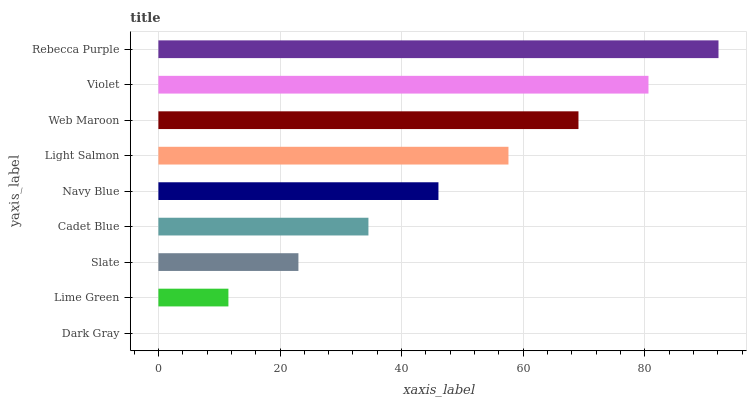Is Dark Gray the minimum?
Answer yes or no. Yes. Is Rebecca Purple the maximum?
Answer yes or no. Yes. Is Lime Green the minimum?
Answer yes or no. No. Is Lime Green the maximum?
Answer yes or no. No. Is Lime Green greater than Dark Gray?
Answer yes or no. Yes. Is Dark Gray less than Lime Green?
Answer yes or no. Yes. Is Dark Gray greater than Lime Green?
Answer yes or no. No. Is Lime Green less than Dark Gray?
Answer yes or no. No. Is Navy Blue the high median?
Answer yes or no. Yes. Is Navy Blue the low median?
Answer yes or no. Yes. Is Rebecca Purple the high median?
Answer yes or no. No. Is Lime Green the low median?
Answer yes or no. No. 